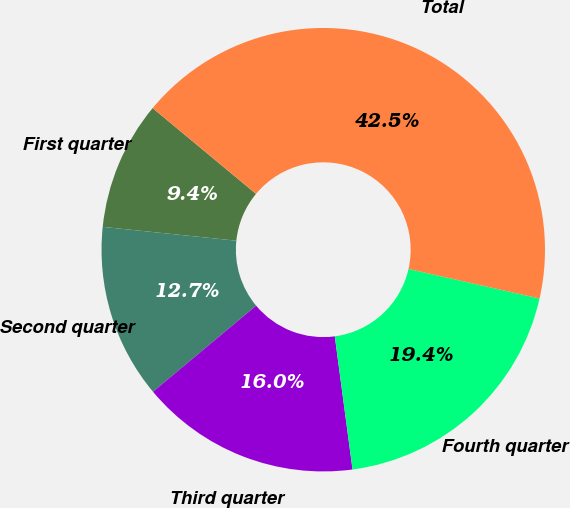<chart> <loc_0><loc_0><loc_500><loc_500><pie_chart><fcel>First quarter<fcel>Second quarter<fcel>Third quarter<fcel>Fourth quarter<fcel>Total<nl><fcel>9.38%<fcel>12.71%<fcel>16.04%<fcel>19.36%<fcel>42.51%<nl></chart> 